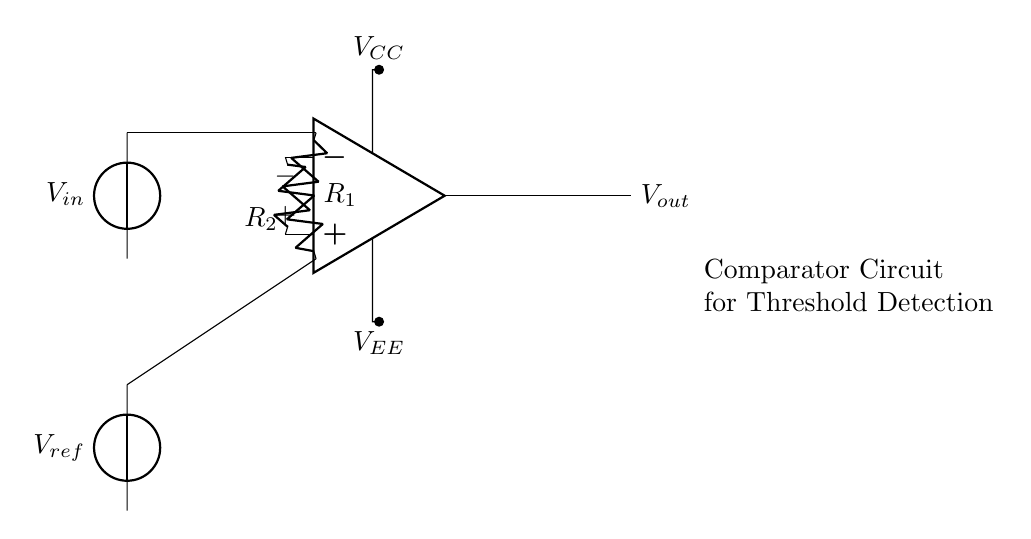What is the input voltage of the circuit? The input voltage, labeled as V_in in the circuit diagram, is connected to the non-inverting terminal of the operational amplifier. It is supplied by a voltage source.
Answer: V_in What is the reference voltage used in this circuit? The reference voltage, labeled as V_ref, is connected to the inverting terminal of the operational amplifier. It is also supplied by a voltage source in the circuit.
Answer: V_ref What are the resistors in this circuit? There are two resistors in this circuit, R_1 and R_2, connected to the non-inverting and inverting terminals of the operational amplifier, respectively.
Answer: R_1, R_2 What happens to the output voltage when the input voltage rises above the reference voltage? When V_in exceeds V_ref, the output of the operational amplifier will switch to its maximum value, which indicates a positive response from the comparator circuit.
Answer: High What kind of circuit is this? This circuit is an operational amplifier-based comparator circuit designed for threshold detection, where it can determine whether the input voltage is above or below a certain threshold level represented by the reference voltage.
Answer: Comparator What is the purpose of the operational amplifier in this configuration? The operational amplifier acts as a comparator that compares the input voltage to the reference voltage and generates a high or low output based on which is greater, facilitating decision-making in distinguishing levels.
Answer: Threshold detection What do the power supply connections labeled V_CC and V_EE represent? V_CC is the positive power supply connection providing the operational amplifier with the necessary positive voltage, while V_EE is the negative supply providing a negative voltage reference for the circuit.
Answer: Power supplies 